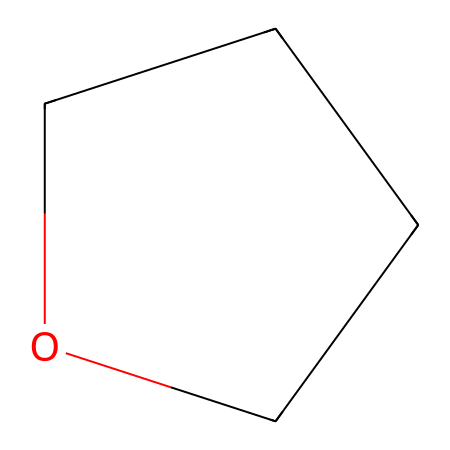how many carbon atoms are present in tetrahydrofuran? The SMILES representation indicates the structure has two carbon atoms denoted as 'C', counted sequentially from the left and right sides of the cyclic structure (C1CC).
Answer: two how many oxygen atoms are present in tetrahydrofuran? In the SMILES notation, the 'O' indicates the presence of one oxygen atom within the ring structure.
Answer: one what type of functional group is present in tetrahydrofuran? Following the structure, the presence of the ether's characteristic oxygen atom bridging two carbon atoms signifies that it contains an ether functional group.
Answer: ether describe the molecular shape of tetrahydrofuran. The cyclic structure formed by four carbon and one oxygen atom suggests a ring-shaped molecular geometry that is typical of tetrahydrofuran.
Answer: ring what is the total number of atoms in tetrahydrofuran? By adding the counts of carbon (4) and oxygen (1), we find a total of five atoms in the molecular structure as observed in the SMILES representation.
Answer: five how many bonds are present in tetrahydrofuran? The structure shows four carbon-carbon bonds and one carbon-oxygen bond, leading to a total of five bonds counted within the cyclic arrangement.
Answer: five why is tetrahydrofuran considered a good solvent for adhesives? The ether functionality allows tetrahydrofuran to effectively solvate and dissolve both polar and non-polar substances, resulting in its high solvency power, which is beneficial for adhesives.
Answer: high solvency 